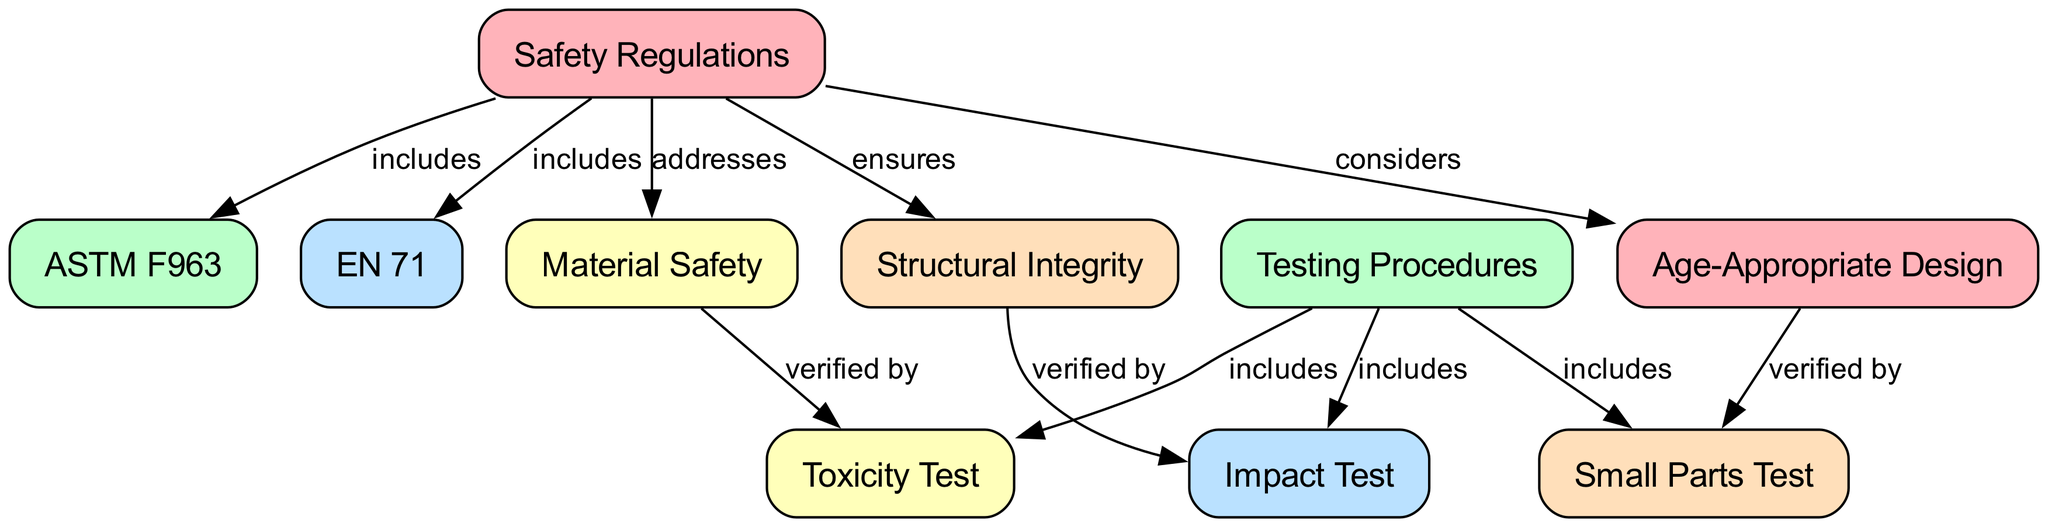What are the two specific safety regulations included in the diagram? The edge connections from "safety_regulations" to "astm" and "en71" indicate that these two regulations are part of the overall safety regulations.
Answer: ASTM F963, EN 71 How many testing procedures are mentioned in the diagram? The "testing_procedures" node connects to three specific testing types: "impact_test," "toxicity_test," and "small_parts_test." Therefore, the total counted from these connections is three.
Answer: 3 Which testing procedure verifies material safety? The "material_safety" node has an edge leading to "toxicity_test," indicating that the toxicity test is how material safety is verified.
Answer: Toxicity Test What considerations does safety regulation include for toy design? The "safety_regulations" node points to "age_appropriate," showing that safety regulation takes into account the age appropriateness in toy design.
Answer: Age-Appropriate Design What is verified by the impact test? The "structural_integrity" node has an edge pointing to "impact_test," meaning that structural integrity is verified by conducting the impact test.
Answer: Structural Integrity How many edges are associated with the safety regulations node? The "safety_regulations" node has edges connecting to five different nodes: "astm," "en71," "material_safety," "structural_integrity," and "age_appropriate," making a total of five edges.
Answer: 5 Which two types of tests are included in testing procedures but do not directly verify structural integrity? The connections show that "toxicity_test" verifies material safety, and "small_parts_test" verifies age appropriateness, both of which are part of testing procedures and not directly linked to structural integrity.
Answer: Toxicity Test, Small Parts Test What topic does structural integrity ensure in the context of safety regulations? The connection from "safety_regulations" to "structural_integrity" indicates that structural integrity ensures safety in toys, protecting children from hazards.
Answer: Safety in Toys 